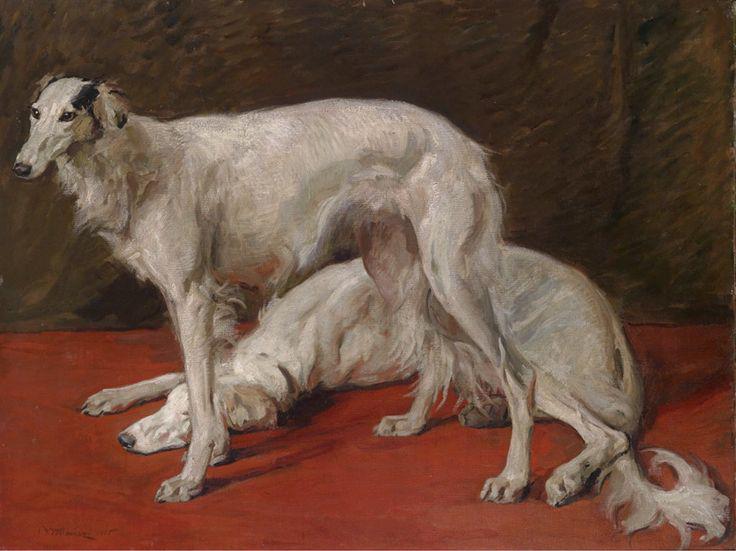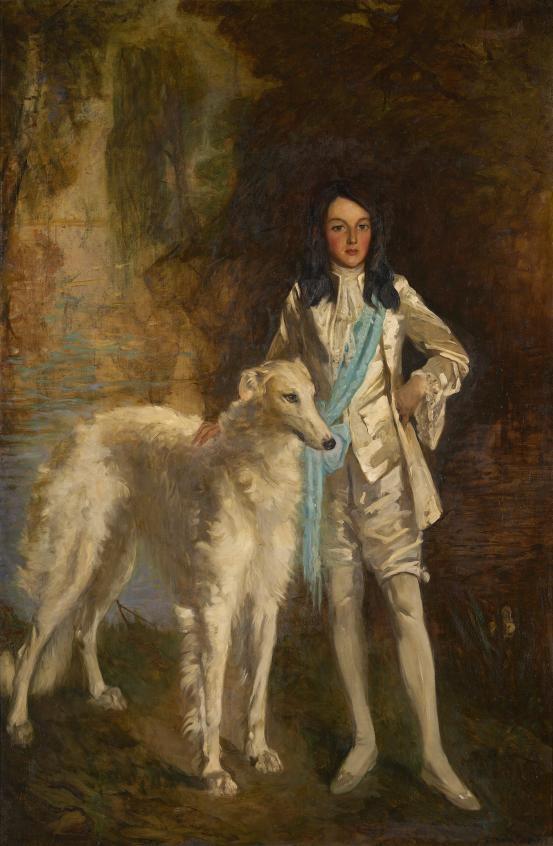The first image is the image on the left, the second image is the image on the right. Analyze the images presented: Is the assertion "An image includes a hound reclining on an animal skin." valid? Answer yes or no. No. 